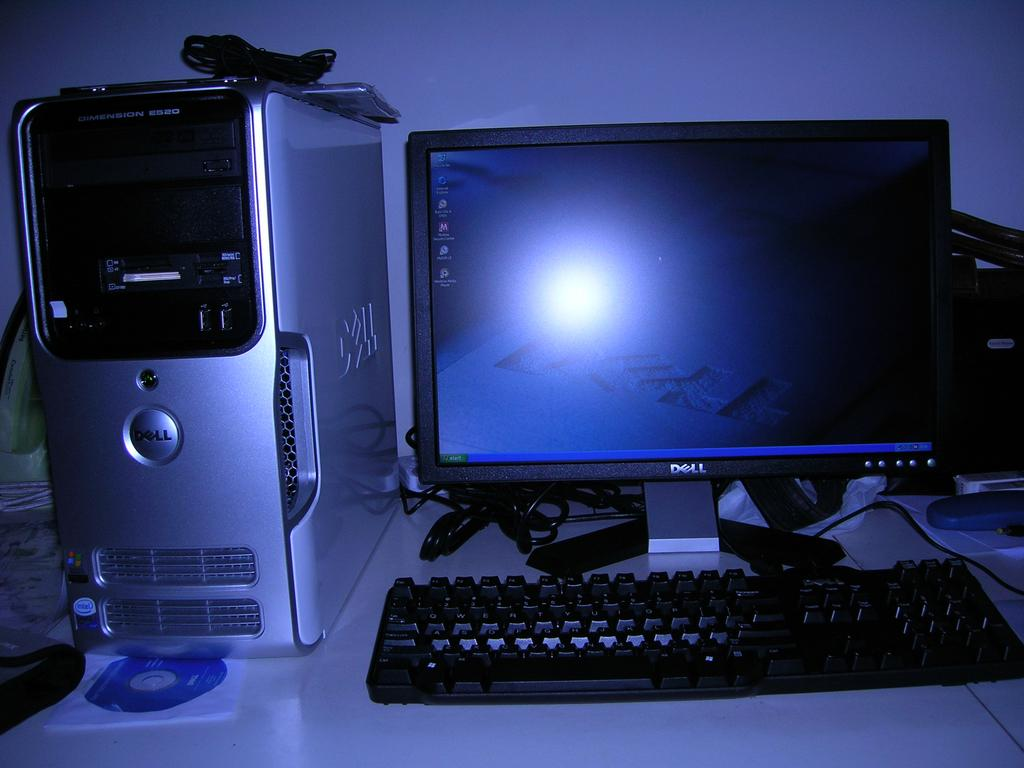<image>
Summarize the visual content of the image. A computer is on a desk next to a tower that says Dell. 